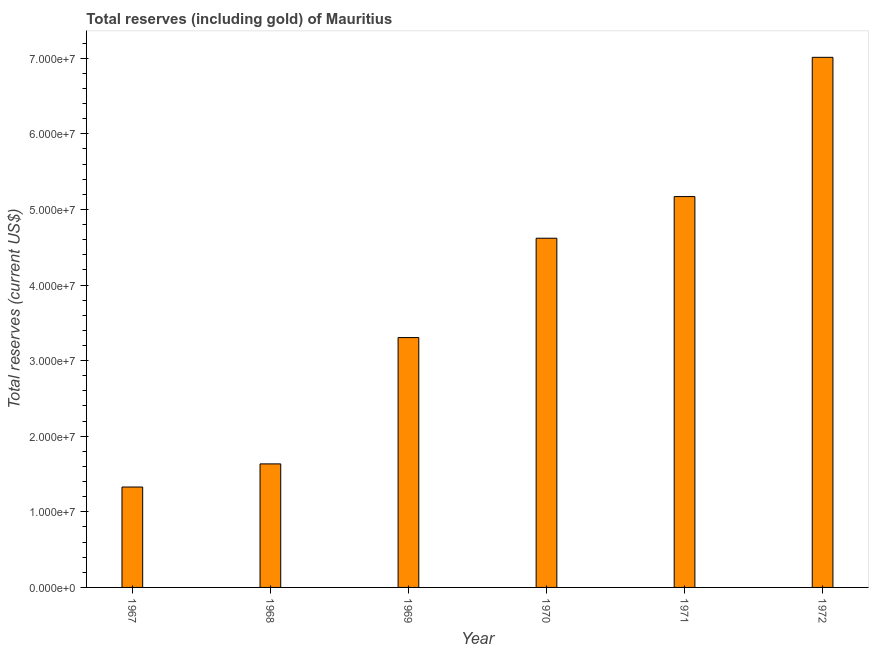What is the title of the graph?
Your response must be concise. Total reserves (including gold) of Mauritius. What is the label or title of the X-axis?
Make the answer very short. Year. What is the label or title of the Y-axis?
Provide a succinct answer. Total reserves (current US$). What is the total reserves (including gold) in 1968?
Give a very brief answer. 1.63e+07. Across all years, what is the maximum total reserves (including gold)?
Make the answer very short. 7.01e+07. Across all years, what is the minimum total reserves (including gold)?
Offer a very short reply. 1.33e+07. In which year was the total reserves (including gold) maximum?
Provide a succinct answer. 1972. In which year was the total reserves (including gold) minimum?
Your answer should be compact. 1967. What is the sum of the total reserves (including gold)?
Your answer should be compact. 2.31e+08. What is the difference between the total reserves (including gold) in 1967 and 1969?
Your answer should be compact. -1.98e+07. What is the average total reserves (including gold) per year?
Make the answer very short. 3.84e+07. What is the median total reserves (including gold)?
Your answer should be very brief. 3.96e+07. In how many years, is the total reserves (including gold) greater than 58000000 US$?
Your answer should be compact. 1. What is the ratio of the total reserves (including gold) in 1967 to that in 1968?
Keep it short and to the point. 0.81. Is the total reserves (including gold) in 1971 less than that in 1972?
Make the answer very short. Yes. What is the difference between the highest and the second highest total reserves (including gold)?
Offer a terse response. 1.84e+07. What is the difference between the highest and the lowest total reserves (including gold)?
Provide a short and direct response. 5.68e+07. How many bars are there?
Ensure brevity in your answer.  6. Are all the bars in the graph horizontal?
Keep it short and to the point. No. How many years are there in the graph?
Keep it short and to the point. 6. What is the difference between two consecutive major ticks on the Y-axis?
Offer a very short reply. 1.00e+07. What is the Total reserves (current US$) of 1967?
Ensure brevity in your answer.  1.33e+07. What is the Total reserves (current US$) of 1968?
Provide a short and direct response. 1.63e+07. What is the Total reserves (current US$) of 1969?
Keep it short and to the point. 3.30e+07. What is the Total reserves (current US$) in 1970?
Ensure brevity in your answer.  4.62e+07. What is the Total reserves (current US$) of 1971?
Provide a short and direct response. 5.17e+07. What is the Total reserves (current US$) in 1972?
Your response must be concise. 7.01e+07. What is the difference between the Total reserves (current US$) in 1967 and 1968?
Keep it short and to the point. -3.06e+06. What is the difference between the Total reserves (current US$) in 1967 and 1969?
Ensure brevity in your answer.  -1.98e+07. What is the difference between the Total reserves (current US$) in 1967 and 1970?
Provide a succinct answer. -3.29e+07. What is the difference between the Total reserves (current US$) in 1967 and 1971?
Your answer should be very brief. -3.84e+07. What is the difference between the Total reserves (current US$) in 1967 and 1972?
Provide a succinct answer. -5.68e+07. What is the difference between the Total reserves (current US$) in 1968 and 1969?
Your answer should be very brief. -1.67e+07. What is the difference between the Total reserves (current US$) in 1968 and 1970?
Offer a terse response. -2.98e+07. What is the difference between the Total reserves (current US$) in 1968 and 1971?
Provide a short and direct response. -3.54e+07. What is the difference between the Total reserves (current US$) in 1968 and 1972?
Your answer should be very brief. -5.38e+07. What is the difference between the Total reserves (current US$) in 1969 and 1970?
Provide a succinct answer. -1.31e+07. What is the difference between the Total reserves (current US$) in 1969 and 1971?
Your answer should be compact. -1.86e+07. What is the difference between the Total reserves (current US$) in 1969 and 1972?
Provide a short and direct response. -3.71e+07. What is the difference between the Total reserves (current US$) in 1970 and 1971?
Provide a short and direct response. -5.51e+06. What is the difference between the Total reserves (current US$) in 1970 and 1972?
Offer a very short reply. -2.39e+07. What is the difference between the Total reserves (current US$) in 1971 and 1972?
Provide a succinct answer. -1.84e+07. What is the ratio of the Total reserves (current US$) in 1967 to that in 1968?
Provide a succinct answer. 0.81. What is the ratio of the Total reserves (current US$) in 1967 to that in 1969?
Your response must be concise. 0.4. What is the ratio of the Total reserves (current US$) in 1967 to that in 1970?
Make the answer very short. 0.29. What is the ratio of the Total reserves (current US$) in 1967 to that in 1971?
Keep it short and to the point. 0.26. What is the ratio of the Total reserves (current US$) in 1967 to that in 1972?
Your answer should be compact. 0.19. What is the ratio of the Total reserves (current US$) in 1968 to that in 1969?
Provide a succinct answer. 0.49. What is the ratio of the Total reserves (current US$) in 1968 to that in 1970?
Give a very brief answer. 0.35. What is the ratio of the Total reserves (current US$) in 1968 to that in 1971?
Offer a terse response. 0.32. What is the ratio of the Total reserves (current US$) in 1968 to that in 1972?
Provide a succinct answer. 0.23. What is the ratio of the Total reserves (current US$) in 1969 to that in 1970?
Make the answer very short. 0.72. What is the ratio of the Total reserves (current US$) in 1969 to that in 1971?
Ensure brevity in your answer.  0.64. What is the ratio of the Total reserves (current US$) in 1969 to that in 1972?
Keep it short and to the point. 0.47. What is the ratio of the Total reserves (current US$) in 1970 to that in 1971?
Offer a very short reply. 0.89. What is the ratio of the Total reserves (current US$) in 1970 to that in 1972?
Your response must be concise. 0.66. What is the ratio of the Total reserves (current US$) in 1971 to that in 1972?
Ensure brevity in your answer.  0.74. 